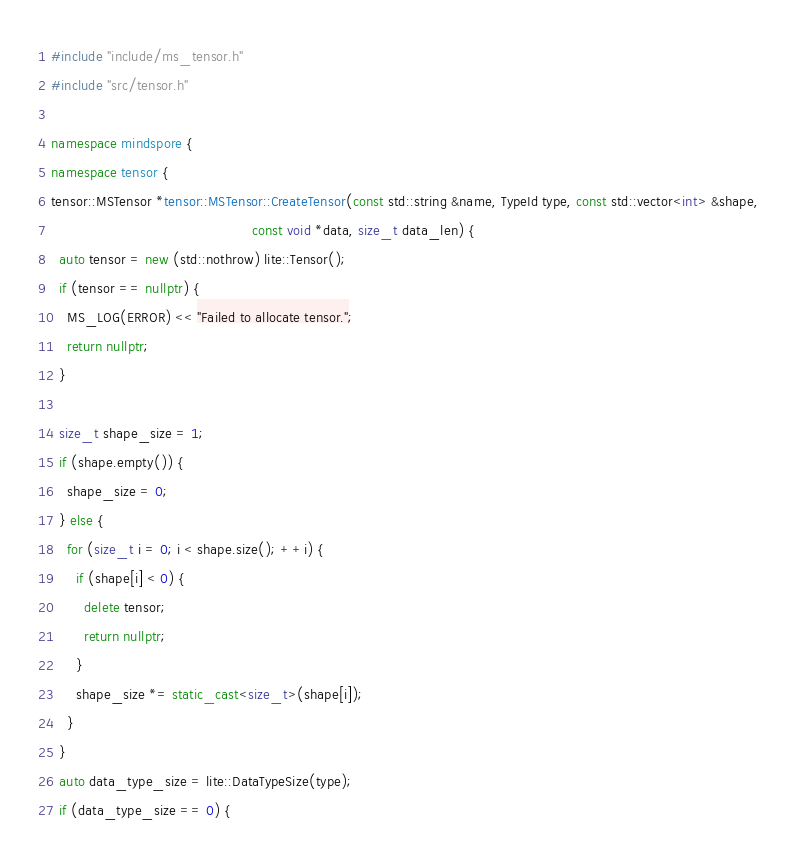<code> <loc_0><loc_0><loc_500><loc_500><_C++_>
#include "include/ms_tensor.h"
#include "src/tensor.h"

namespace mindspore {
namespace tensor {
tensor::MSTensor *tensor::MSTensor::CreateTensor(const std::string &name, TypeId type, const std::vector<int> &shape,
                                                 const void *data, size_t data_len) {
  auto tensor = new (std::nothrow) lite::Tensor();
  if (tensor == nullptr) {
    MS_LOG(ERROR) << "Failed to allocate tensor.";
    return nullptr;
  }

  size_t shape_size = 1;
  if (shape.empty()) {
    shape_size = 0;
  } else {
    for (size_t i = 0; i < shape.size(); ++i) {
      if (shape[i] < 0) {
        delete tensor;
        return nullptr;
      }
      shape_size *= static_cast<size_t>(shape[i]);
    }
  }
  auto data_type_size = lite::DataTypeSize(type);
  if (data_type_size == 0) {</code> 